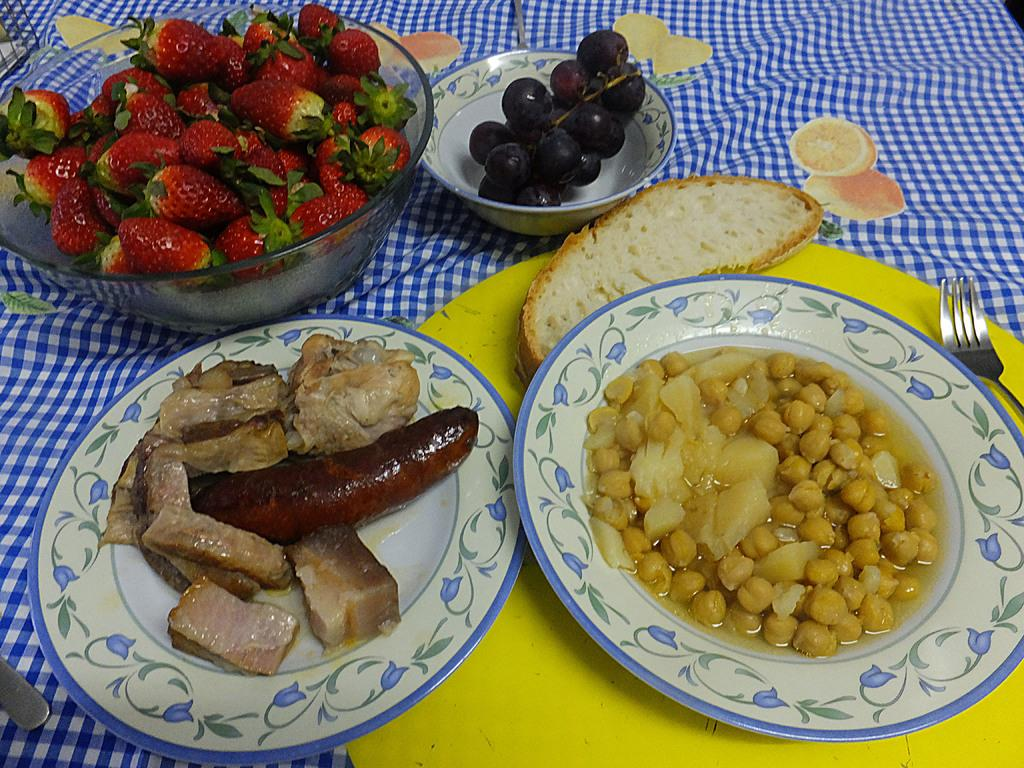What type of food can be seen in the image? There is food in the image, including fruits in bowls. What utensil is present in the image? There is a fork in the image. How are the fruits arranged in the image? The fruits are in bowls in the image. What type of disease is being treated in the image? There is no indication of a disease or treatment in the image; it features food, a fork, and fruits in bowls. 